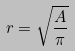Convert formula to latex. <formula><loc_0><loc_0><loc_500><loc_500>r = \sqrt { \frac { A } { \pi } }</formula> 